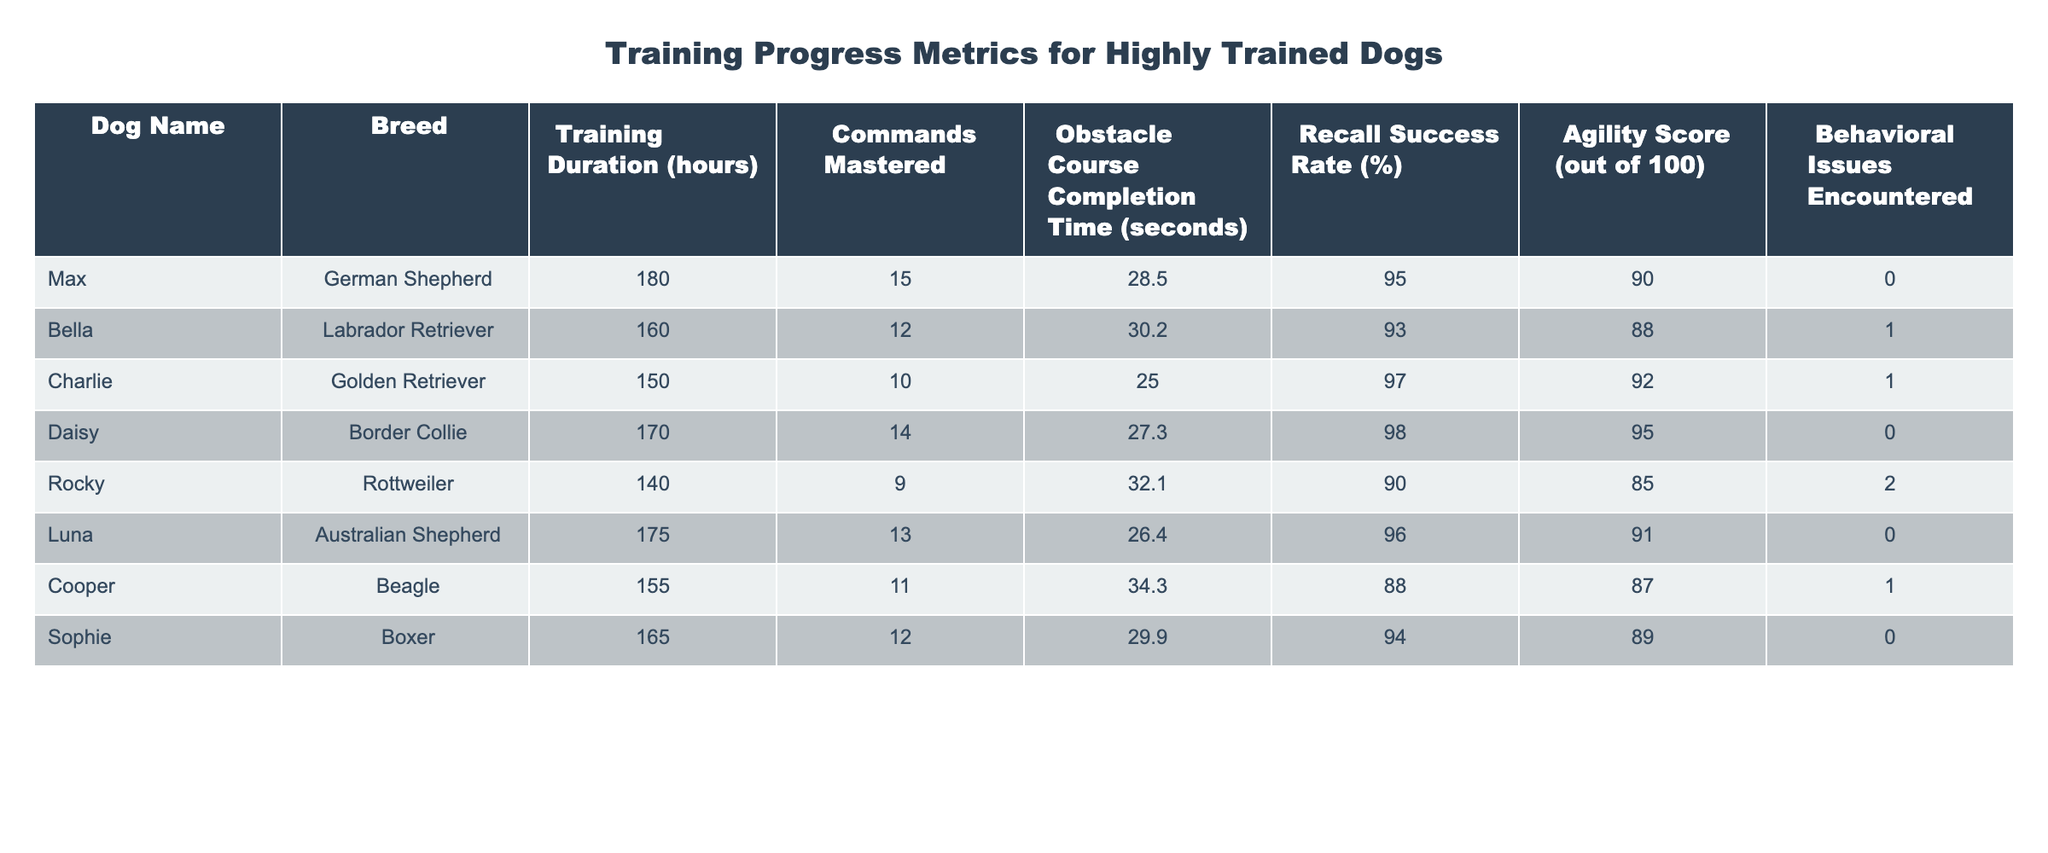What is the average training duration for the pack of dogs? The training durations for the dogs are 180, 160, 150, 170, 140, 175, 155, and 165 hours. Adding these values gives a total of 1,130 hours. There are 8 dogs, so the average is calculated as 1,130 / 8 = 141.25 hours.
Answer: 141.25 hours Which dog has the highest recall success rate? The recall success rates are 95% for Max, 93% for Bella, 97% for Charlie, 98% for Daisy, 90% for Rocky, 96% for Luna, 88% for Cooper, and 94% for Sophie. The highest value is 98% for Daisy.
Answer: Daisy Did any dog encounter behavioral issues during training? The behavioral issues encountered are listed as 0 for Max, 1 for Bella, 1 for Charlie, 0 for Daisy, 2 for Rocky, 0 for Luna, 1 for Cooper, and 0 for Sophie. Since there are dogs with a count greater than zero, the answer is yes.
Answer: Yes What is the total number of commands mastered by all dogs? The commands mastered are 15 for Max, 12 for Bella, 10 for Charlie, 14 for Daisy, 9 for Rocky, 13 for Luna, 11 for Cooper, and 12 for Sophie. Summing these gives 15 + 12 + 10 + 14 + 9 + 13 + 11 + 12 = 96.
Answer: 96 Which dog had the longest obstacle course completion time, and what was that time? The obstacle course completion times are 28.5 for Max, 30.2 for Bella, 25.0 for Charlie, 27.3 for Daisy, 32.1 for Rocky, 26.4 for Luna, 34.3 for Cooper, and 29.9 for Sophie. The longest time is 34.3 seconds for Cooper.
Answer: Cooper, 34.3 seconds What is the average agility score of the dogs encountering behavioral issues? The agility scores for dogs with behavioral issues are 88 for Bella, 92 for Charlie, 85 for Rocky, and 87 for Cooper. To find the average, sum these scores (88 + 92 + 85 + 87) = 352, then divide by the number of dogs with issues (4), resulting in 352 / 4 = 88.
Answer: 88 Is there a dog that scored exactly 90 in agility? The agility scores listed are 90 for Max, 88 for Bella, 92 for Charlie, 95 for Daisy, 85 for Rocky, 91 for Luna, 87 for Cooper, and 89 for Sophie. Since Max scored exactly 90, the answer is yes.
Answer: Yes Which dog has the highest number of behavioral issues, and what was the count? The counts of behavioral issues are 0 for Max, 1 for Bella, 1 for Charlie, 0 for Daisy, 2 for Rocky, 0 for Luna, 1 for Cooper, and 0 for Sophie. The highest count is 2 for Rocky.
Answer: Rocky, 2 